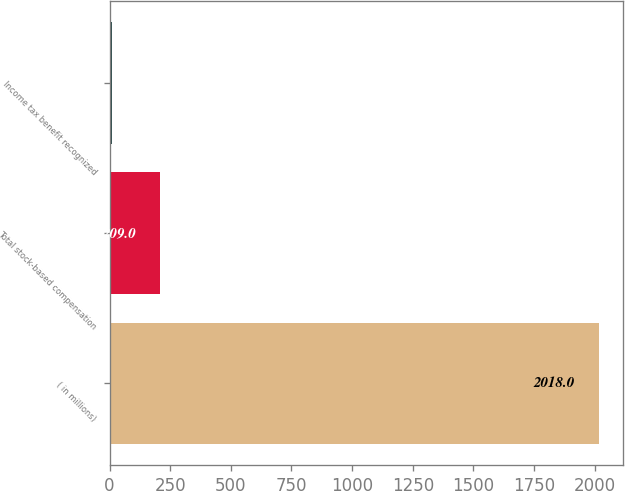Convert chart to OTSL. <chart><loc_0><loc_0><loc_500><loc_500><bar_chart><fcel>( in millions)<fcel>Total stock-based compensation<fcel>Income tax benefit recognized<nl><fcel>2018<fcel>209<fcel>8<nl></chart> 